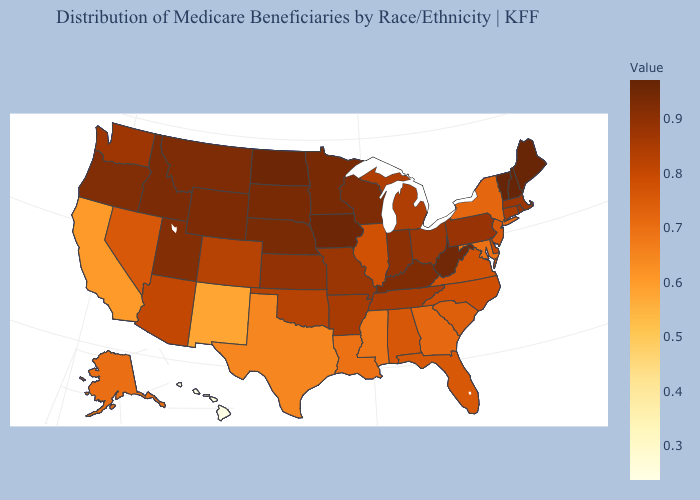Does Wyoming have the highest value in the West?
Concise answer only. No. 